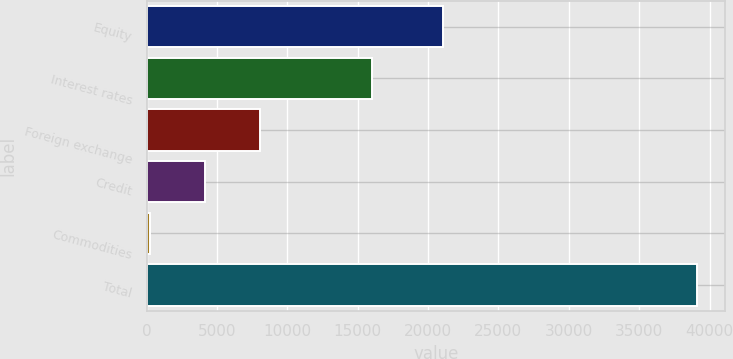Convert chart to OTSL. <chart><loc_0><loc_0><loc_500><loc_500><bar_chart><fcel>Equity<fcel>Interest rates<fcel>Foreign exchange<fcel>Credit<fcel>Commodities<fcel>Total<nl><fcel>21066<fcel>16051<fcel>8039.6<fcel>4151.8<fcel>264<fcel>39142<nl></chart> 